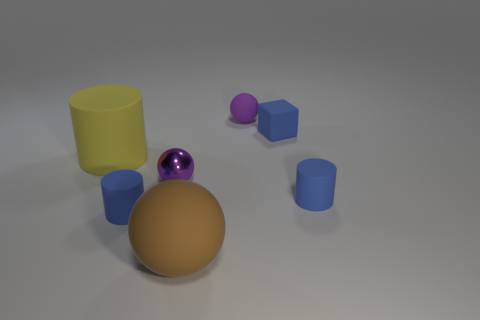Add 2 yellow matte cylinders. How many objects exist? 9 Subtract all cylinders. How many objects are left? 4 Subtract all big rubber balls. Subtract all purple matte spheres. How many objects are left? 5 Add 7 brown balls. How many brown balls are left? 8 Add 7 tiny cyan metallic balls. How many tiny cyan metallic balls exist? 7 Subtract 0 green cylinders. How many objects are left? 7 